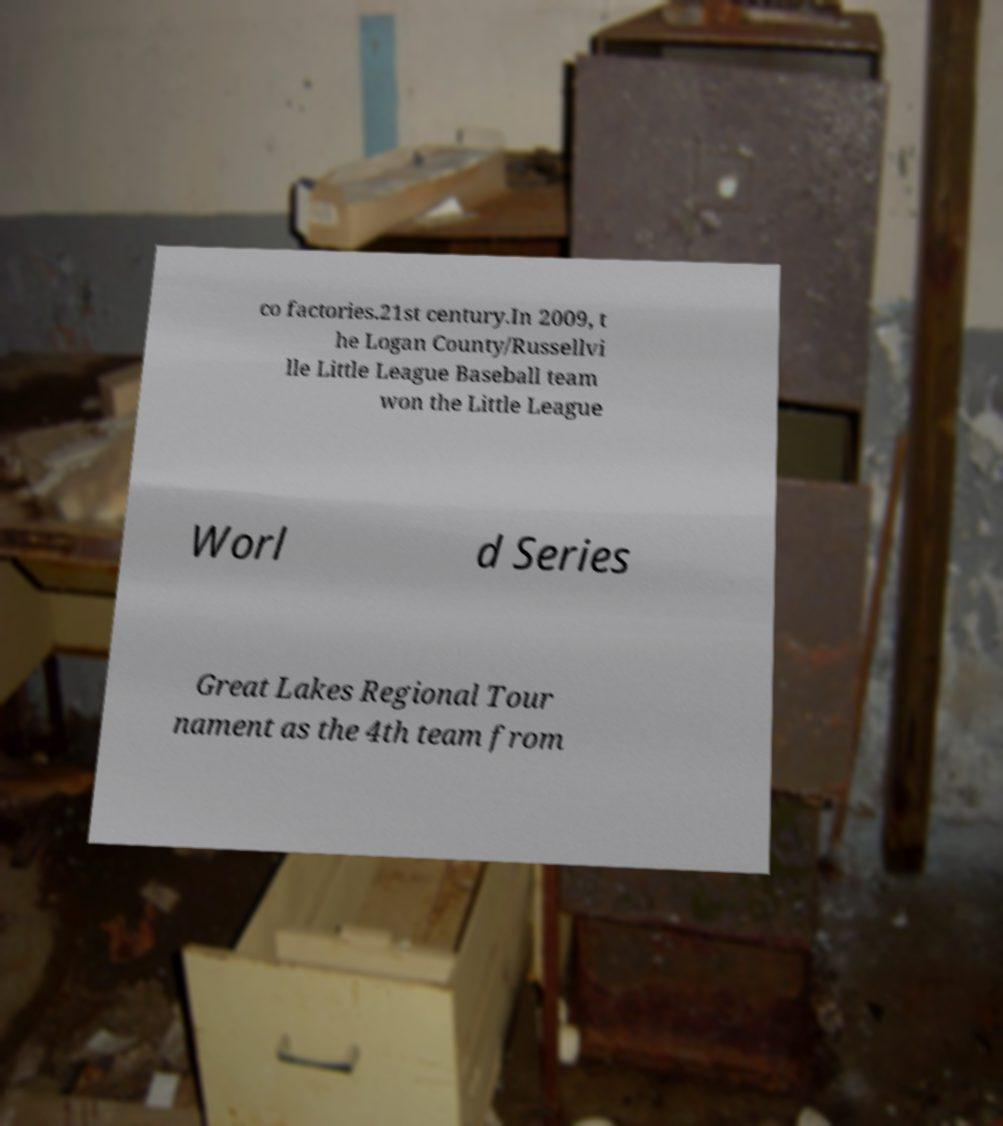Can you accurately transcribe the text from the provided image for me? co factories.21st century.In 2009, t he Logan County/Russellvi lle Little League Baseball team won the Little League Worl d Series Great Lakes Regional Tour nament as the 4th team from 